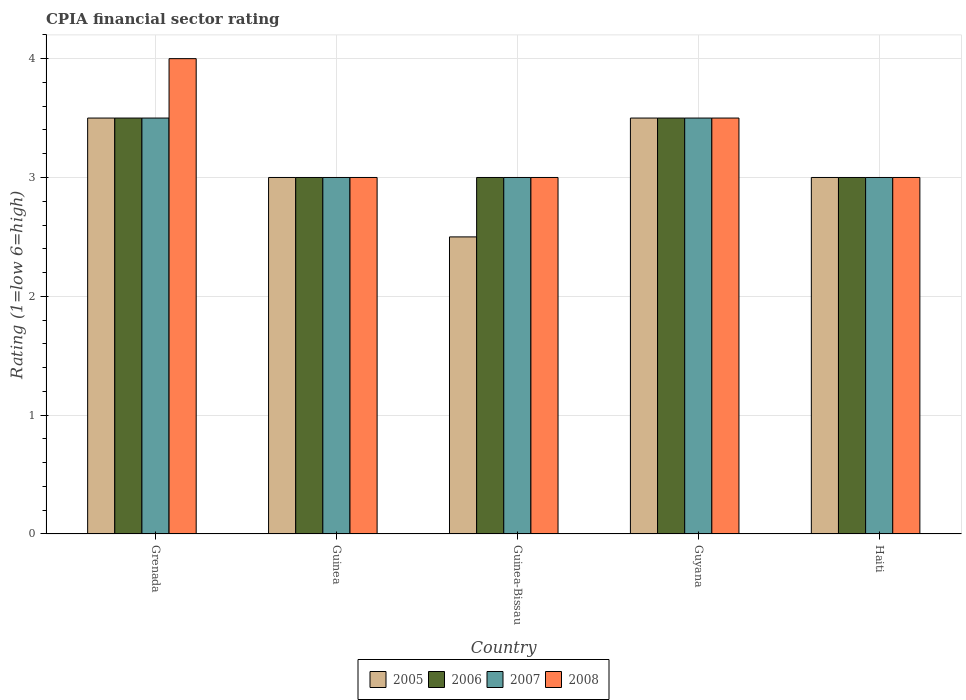Are the number of bars per tick equal to the number of legend labels?
Your answer should be compact. Yes. Are the number of bars on each tick of the X-axis equal?
Your answer should be compact. Yes. How many bars are there on the 2nd tick from the left?
Keep it short and to the point. 4. What is the label of the 1st group of bars from the left?
Your answer should be very brief. Grenada. In how many cases, is the number of bars for a given country not equal to the number of legend labels?
Offer a very short reply. 0. Across all countries, what is the maximum CPIA rating in 2005?
Your answer should be compact. 3.5. Across all countries, what is the minimum CPIA rating in 2005?
Give a very brief answer. 2.5. In which country was the CPIA rating in 2007 maximum?
Provide a succinct answer. Grenada. In which country was the CPIA rating in 2005 minimum?
Offer a very short reply. Guinea-Bissau. What is the difference between the CPIA rating in 2008 in Grenada and that in Haiti?
Make the answer very short. 1. Is the difference between the CPIA rating in 2005 in Guinea and Guinea-Bissau greater than the difference between the CPIA rating in 2007 in Guinea and Guinea-Bissau?
Offer a terse response. Yes. What is the difference between the highest and the lowest CPIA rating in 2007?
Ensure brevity in your answer.  0.5. In how many countries, is the CPIA rating in 2005 greater than the average CPIA rating in 2005 taken over all countries?
Keep it short and to the point. 2. Is it the case that in every country, the sum of the CPIA rating in 2005 and CPIA rating in 2008 is greater than the sum of CPIA rating in 2007 and CPIA rating in 2006?
Offer a terse response. No. Is it the case that in every country, the sum of the CPIA rating in 2007 and CPIA rating in 2005 is greater than the CPIA rating in 2006?
Keep it short and to the point. Yes. How many bars are there?
Make the answer very short. 20. Are all the bars in the graph horizontal?
Keep it short and to the point. No. How many countries are there in the graph?
Offer a very short reply. 5. What is the difference between two consecutive major ticks on the Y-axis?
Make the answer very short. 1. Are the values on the major ticks of Y-axis written in scientific E-notation?
Provide a succinct answer. No. Does the graph contain any zero values?
Offer a very short reply. No. Does the graph contain grids?
Your response must be concise. Yes. How many legend labels are there?
Ensure brevity in your answer.  4. How are the legend labels stacked?
Your response must be concise. Horizontal. What is the title of the graph?
Ensure brevity in your answer.  CPIA financial sector rating. What is the Rating (1=low 6=high) of 2005 in Grenada?
Give a very brief answer. 3.5. What is the Rating (1=low 6=high) in 2008 in Grenada?
Provide a short and direct response. 4. What is the Rating (1=low 6=high) in 2005 in Guinea?
Your response must be concise. 3. What is the Rating (1=low 6=high) of 2006 in Guinea?
Make the answer very short. 3. What is the Rating (1=low 6=high) of 2007 in Guinea-Bissau?
Your response must be concise. 3. What is the Rating (1=low 6=high) of 2005 in Guyana?
Offer a very short reply. 3.5. What is the Rating (1=low 6=high) of 2007 in Guyana?
Offer a very short reply. 3.5. What is the Rating (1=low 6=high) in 2005 in Haiti?
Your answer should be compact. 3. What is the Rating (1=low 6=high) of 2006 in Haiti?
Your answer should be compact. 3. What is the Rating (1=low 6=high) of 2008 in Haiti?
Ensure brevity in your answer.  3. Across all countries, what is the maximum Rating (1=low 6=high) of 2005?
Offer a very short reply. 3.5. Across all countries, what is the maximum Rating (1=low 6=high) of 2007?
Give a very brief answer. 3.5. Across all countries, what is the maximum Rating (1=low 6=high) in 2008?
Keep it short and to the point. 4. Across all countries, what is the minimum Rating (1=low 6=high) in 2005?
Offer a terse response. 2.5. Across all countries, what is the minimum Rating (1=low 6=high) in 2006?
Offer a terse response. 3. Across all countries, what is the minimum Rating (1=low 6=high) in 2007?
Provide a succinct answer. 3. Across all countries, what is the minimum Rating (1=low 6=high) of 2008?
Keep it short and to the point. 3. What is the total Rating (1=low 6=high) in 2005 in the graph?
Make the answer very short. 15.5. What is the total Rating (1=low 6=high) in 2007 in the graph?
Provide a short and direct response. 16. What is the total Rating (1=low 6=high) in 2008 in the graph?
Your answer should be very brief. 16.5. What is the difference between the Rating (1=low 6=high) in 2006 in Grenada and that in Guinea?
Your answer should be compact. 0.5. What is the difference between the Rating (1=low 6=high) of 2007 in Grenada and that in Guinea?
Your answer should be very brief. 0.5. What is the difference between the Rating (1=low 6=high) in 2006 in Grenada and that in Guinea-Bissau?
Offer a terse response. 0.5. What is the difference between the Rating (1=low 6=high) in 2007 in Grenada and that in Guinea-Bissau?
Offer a terse response. 0.5. What is the difference between the Rating (1=low 6=high) of 2008 in Grenada and that in Guinea-Bissau?
Provide a succinct answer. 1. What is the difference between the Rating (1=low 6=high) of 2008 in Grenada and that in Guyana?
Offer a very short reply. 0.5. What is the difference between the Rating (1=low 6=high) of 2005 in Grenada and that in Haiti?
Make the answer very short. 0.5. What is the difference between the Rating (1=low 6=high) in 2006 in Grenada and that in Haiti?
Offer a very short reply. 0.5. What is the difference between the Rating (1=low 6=high) in 2007 in Grenada and that in Haiti?
Keep it short and to the point. 0.5. What is the difference between the Rating (1=low 6=high) of 2005 in Guinea and that in Guinea-Bissau?
Your answer should be compact. 0.5. What is the difference between the Rating (1=low 6=high) in 2006 in Guinea and that in Guinea-Bissau?
Ensure brevity in your answer.  0. What is the difference between the Rating (1=low 6=high) in 2008 in Guinea and that in Guinea-Bissau?
Your response must be concise. 0. What is the difference between the Rating (1=low 6=high) of 2005 in Guinea and that in Guyana?
Give a very brief answer. -0.5. What is the difference between the Rating (1=low 6=high) in 2006 in Guinea and that in Guyana?
Your response must be concise. -0.5. What is the difference between the Rating (1=low 6=high) in 2007 in Guinea and that in Guyana?
Your response must be concise. -0.5. What is the difference between the Rating (1=low 6=high) of 2005 in Guinea and that in Haiti?
Keep it short and to the point. 0. What is the difference between the Rating (1=low 6=high) in 2006 in Guinea and that in Haiti?
Provide a short and direct response. 0. What is the difference between the Rating (1=low 6=high) of 2008 in Guinea and that in Haiti?
Ensure brevity in your answer.  0. What is the difference between the Rating (1=low 6=high) of 2005 in Guinea-Bissau and that in Guyana?
Provide a succinct answer. -1. What is the difference between the Rating (1=low 6=high) in 2006 in Guinea-Bissau and that in Guyana?
Offer a terse response. -0.5. What is the difference between the Rating (1=low 6=high) of 2005 in Guinea-Bissau and that in Haiti?
Make the answer very short. -0.5. What is the difference between the Rating (1=low 6=high) of 2006 in Guinea-Bissau and that in Haiti?
Provide a short and direct response. 0. What is the difference between the Rating (1=low 6=high) of 2006 in Guyana and that in Haiti?
Keep it short and to the point. 0.5. What is the difference between the Rating (1=low 6=high) in 2007 in Guyana and that in Haiti?
Ensure brevity in your answer.  0.5. What is the difference between the Rating (1=low 6=high) in 2005 in Grenada and the Rating (1=low 6=high) in 2006 in Guinea?
Ensure brevity in your answer.  0.5. What is the difference between the Rating (1=low 6=high) of 2005 in Grenada and the Rating (1=low 6=high) of 2008 in Guinea?
Offer a terse response. 0.5. What is the difference between the Rating (1=low 6=high) in 2006 in Grenada and the Rating (1=low 6=high) in 2007 in Guinea?
Ensure brevity in your answer.  0.5. What is the difference between the Rating (1=low 6=high) in 2006 in Grenada and the Rating (1=low 6=high) in 2008 in Guinea?
Your answer should be compact. 0.5. What is the difference between the Rating (1=low 6=high) in 2007 in Grenada and the Rating (1=low 6=high) in 2008 in Guinea?
Make the answer very short. 0.5. What is the difference between the Rating (1=low 6=high) in 2005 in Grenada and the Rating (1=low 6=high) in 2006 in Guinea-Bissau?
Make the answer very short. 0.5. What is the difference between the Rating (1=low 6=high) of 2005 in Grenada and the Rating (1=low 6=high) of 2007 in Guinea-Bissau?
Make the answer very short. 0.5. What is the difference between the Rating (1=low 6=high) of 2005 in Grenada and the Rating (1=low 6=high) of 2008 in Guinea-Bissau?
Offer a terse response. 0.5. What is the difference between the Rating (1=low 6=high) of 2006 in Grenada and the Rating (1=low 6=high) of 2007 in Guinea-Bissau?
Offer a terse response. 0.5. What is the difference between the Rating (1=low 6=high) in 2007 in Grenada and the Rating (1=low 6=high) in 2008 in Guinea-Bissau?
Your response must be concise. 0.5. What is the difference between the Rating (1=low 6=high) in 2005 in Grenada and the Rating (1=low 6=high) in 2008 in Guyana?
Provide a succinct answer. 0. What is the difference between the Rating (1=low 6=high) in 2006 in Grenada and the Rating (1=low 6=high) in 2007 in Guyana?
Make the answer very short. 0. What is the difference between the Rating (1=low 6=high) of 2006 in Grenada and the Rating (1=low 6=high) of 2008 in Guyana?
Provide a succinct answer. 0. What is the difference between the Rating (1=low 6=high) in 2007 in Grenada and the Rating (1=low 6=high) in 2008 in Guyana?
Your answer should be very brief. 0. What is the difference between the Rating (1=low 6=high) of 2006 in Grenada and the Rating (1=low 6=high) of 2008 in Haiti?
Your response must be concise. 0.5. What is the difference between the Rating (1=low 6=high) of 2005 in Guinea and the Rating (1=low 6=high) of 2008 in Guinea-Bissau?
Your answer should be compact. 0. What is the difference between the Rating (1=low 6=high) in 2006 in Guinea and the Rating (1=low 6=high) in 2008 in Guinea-Bissau?
Ensure brevity in your answer.  0. What is the difference between the Rating (1=low 6=high) in 2007 in Guinea and the Rating (1=low 6=high) in 2008 in Guinea-Bissau?
Ensure brevity in your answer.  0. What is the difference between the Rating (1=low 6=high) of 2005 in Guinea and the Rating (1=low 6=high) of 2006 in Guyana?
Give a very brief answer. -0.5. What is the difference between the Rating (1=low 6=high) of 2005 in Guinea and the Rating (1=low 6=high) of 2007 in Guyana?
Offer a very short reply. -0.5. What is the difference between the Rating (1=low 6=high) in 2006 in Guinea and the Rating (1=low 6=high) in 2007 in Guyana?
Your response must be concise. -0.5. What is the difference between the Rating (1=low 6=high) of 2006 in Guinea and the Rating (1=low 6=high) of 2008 in Guyana?
Make the answer very short. -0.5. What is the difference between the Rating (1=low 6=high) in 2007 in Guinea and the Rating (1=low 6=high) in 2008 in Guyana?
Provide a short and direct response. -0.5. What is the difference between the Rating (1=low 6=high) in 2005 in Guinea and the Rating (1=low 6=high) in 2007 in Haiti?
Ensure brevity in your answer.  0. What is the difference between the Rating (1=low 6=high) in 2005 in Guinea and the Rating (1=low 6=high) in 2008 in Haiti?
Offer a very short reply. 0. What is the difference between the Rating (1=low 6=high) in 2006 in Guinea and the Rating (1=low 6=high) in 2007 in Haiti?
Ensure brevity in your answer.  0. What is the difference between the Rating (1=low 6=high) of 2006 in Guinea and the Rating (1=low 6=high) of 2008 in Haiti?
Offer a terse response. 0. What is the difference between the Rating (1=low 6=high) of 2005 in Guinea-Bissau and the Rating (1=low 6=high) of 2006 in Guyana?
Give a very brief answer. -1. What is the difference between the Rating (1=low 6=high) of 2007 in Guinea-Bissau and the Rating (1=low 6=high) of 2008 in Guyana?
Make the answer very short. -0.5. What is the difference between the Rating (1=low 6=high) of 2006 in Guinea-Bissau and the Rating (1=low 6=high) of 2007 in Haiti?
Provide a succinct answer. 0. What is the difference between the Rating (1=low 6=high) in 2006 in Guinea-Bissau and the Rating (1=low 6=high) in 2008 in Haiti?
Make the answer very short. 0. What is the difference between the Rating (1=low 6=high) in 2005 in Guyana and the Rating (1=low 6=high) in 2006 in Haiti?
Your response must be concise. 0.5. What is the difference between the Rating (1=low 6=high) of 2006 in Guyana and the Rating (1=low 6=high) of 2008 in Haiti?
Ensure brevity in your answer.  0.5. What is the average Rating (1=low 6=high) of 2005 per country?
Make the answer very short. 3.1. What is the average Rating (1=low 6=high) of 2007 per country?
Ensure brevity in your answer.  3.2. What is the difference between the Rating (1=low 6=high) of 2005 and Rating (1=low 6=high) of 2006 in Grenada?
Offer a very short reply. 0. What is the difference between the Rating (1=low 6=high) in 2005 and Rating (1=low 6=high) in 2007 in Guinea?
Your answer should be compact. 0. What is the difference between the Rating (1=low 6=high) of 2005 and Rating (1=low 6=high) of 2008 in Guinea?
Give a very brief answer. 0. What is the difference between the Rating (1=low 6=high) in 2005 and Rating (1=low 6=high) in 2006 in Guinea-Bissau?
Provide a succinct answer. -0.5. What is the difference between the Rating (1=low 6=high) of 2006 and Rating (1=low 6=high) of 2007 in Guinea-Bissau?
Your response must be concise. 0. What is the difference between the Rating (1=low 6=high) in 2006 and Rating (1=low 6=high) in 2008 in Guinea-Bissau?
Provide a succinct answer. 0. What is the difference between the Rating (1=low 6=high) of 2007 and Rating (1=low 6=high) of 2008 in Guinea-Bissau?
Provide a short and direct response. 0. What is the difference between the Rating (1=low 6=high) of 2007 and Rating (1=low 6=high) of 2008 in Guyana?
Keep it short and to the point. 0. What is the difference between the Rating (1=low 6=high) in 2005 and Rating (1=low 6=high) in 2007 in Haiti?
Ensure brevity in your answer.  0. What is the difference between the Rating (1=low 6=high) in 2005 and Rating (1=low 6=high) in 2008 in Haiti?
Your answer should be very brief. 0. What is the difference between the Rating (1=low 6=high) of 2006 and Rating (1=low 6=high) of 2007 in Haiti?
Ensure brevity in your answer.  0. What is the ratio of the Rating (1=low 6=high) of 2005 in Grenada to that in Guinea?
Your answer should be very brief. 1.17. What is the ratio of the Rating (1=low 6=high) of 2006 in Grenada to that in Guinea?
Your answer should be compact. 1.17. What is the ratio of the Rating (1=low 6=high) in 2006 in Grenada to that in Guinea-Bissau?
Your answer should be compact. 1.17. What is the ratio of the Rating (1=low 6=high) of 2007 in Grenada to that in Guinea-Bissau?
Your answer should be compact. 1.17. What is the ratio of the Rating (1=low 6=high) in 2005 in Grenada to that in Guyana?
Your answer should be compact. 1. What is the ratio of the Rating (1=low 6=high) in 2007 in Grenada to that in Guyana?
Ensure brevity in your answer.  1. What is the ratio of the Rating (1=low 6=high) in 2005 in Grenada to that in Haiti?
Provide a succinct answer. 1.17. What is the ratio of the Rating (1=low 6=high) of 2006 in Grenada to that in Haiti?
Provide a short and direct response. 1.17. What is the ratio of the Rating (1=low 6=high) in 2006 in Guinea to that in Guinea-Bissau?
Make the answer very short. 1. What is the ratio of the Rating (1=low 6=high) in 2007 in Guinea to that in Guinea-Bissau?
Offer a very short reply. 1. What is the ratio of the Rating (1=low 6=high) in 2008 in Guinea to that in Guinea-Bissau?
Keep it short and to the point. 1. What is the ratio of the Rating (1=low 6=high) in 2005 in Guinea to that in Guyana?
Offer a very short reply. 0.86. What is the ratio of the Rating (1=low 6=high) of 2007 in Guinea to that in Guyana?
Your answer should be very brief. 0.86. What is the ratio of the Rating (1=low 6=high) of 2008 in Guinea to that in Guyana?
Ensure brevity in your answer.  0.86. What is the ratio of the Rating (1=low 6=high) of 2007 in Guinea to that in Haiti?
Provide a short and direct response. 1. What is the ratio of the Rating (1=low 6=high) of 2005 in Guinea-Bissau to that in Guyana?
Offer a terse response. 0.71. What is the ratio of the Rating (1=low 6=high) of 2006 in Guinea-Bissau to that in Guyana?
Provide a succinct answer. 0.86. What is the ratio of the Rating (1=low 6=high) of 2008 in Guinea-Bissau to that in Guyana?
Keep it short and to the point. 0.86. What is the ratio of the Rating (1=low 6=high) in 2006 in Guinea-Bissau to that in Haiti?
Provide a short and direct response. 1. What is the ratio of the Rating (1=low 6=high) in 2007 in Guinea-Bissau to that in Haiti?
Make the answer very short. 1. What is the difference between the highest and the second highest Rating (1=low 6=high) of 2006?
Ensure brevity in your answer.  0. What is the difference between the highest and the second highest Rating (1=low 6=high) in 2007?
Provide a short and direct response. 0. What is the difference between the highest and the lowest Rating (1=low 6=high) in 2008?
Keep it short and to the point. 1. 